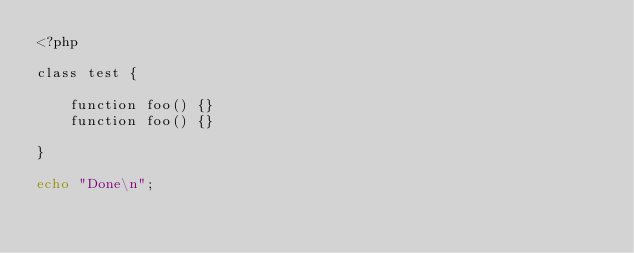<code> <loc_0><loc_0><loc_500><loc_500><_PHP_><?php

class test {

	function foo() {}
	function foo() {}

}

echo "Done\n";
</code> 